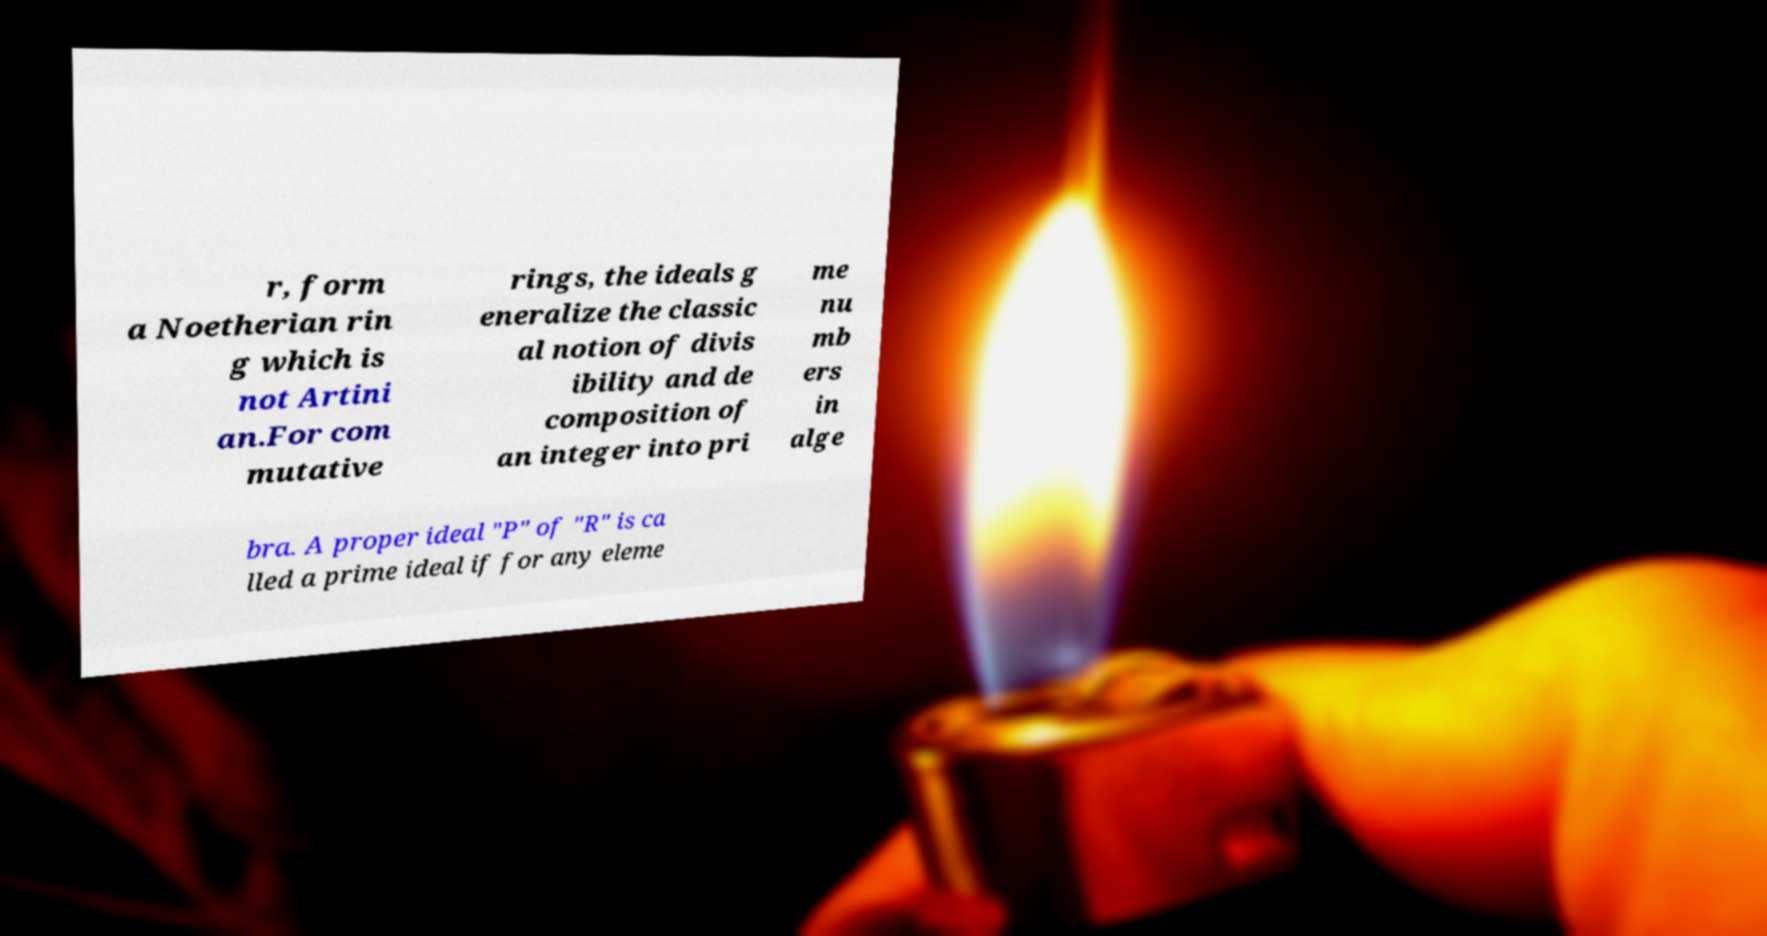Can you read and provide the text displayed in the image?This photo seems to have some interesting text. Can you extract and type it out for me? r, form a Noetherian rin g which is not Artini an.For com mutative rings, the ideals g eneralize the classic al notion of divis ibility and de composition of an integer into pri me nu mb ers in alge bra. A proper ideal "P" of "R" is ca lled a prime ideal if for any eleme 